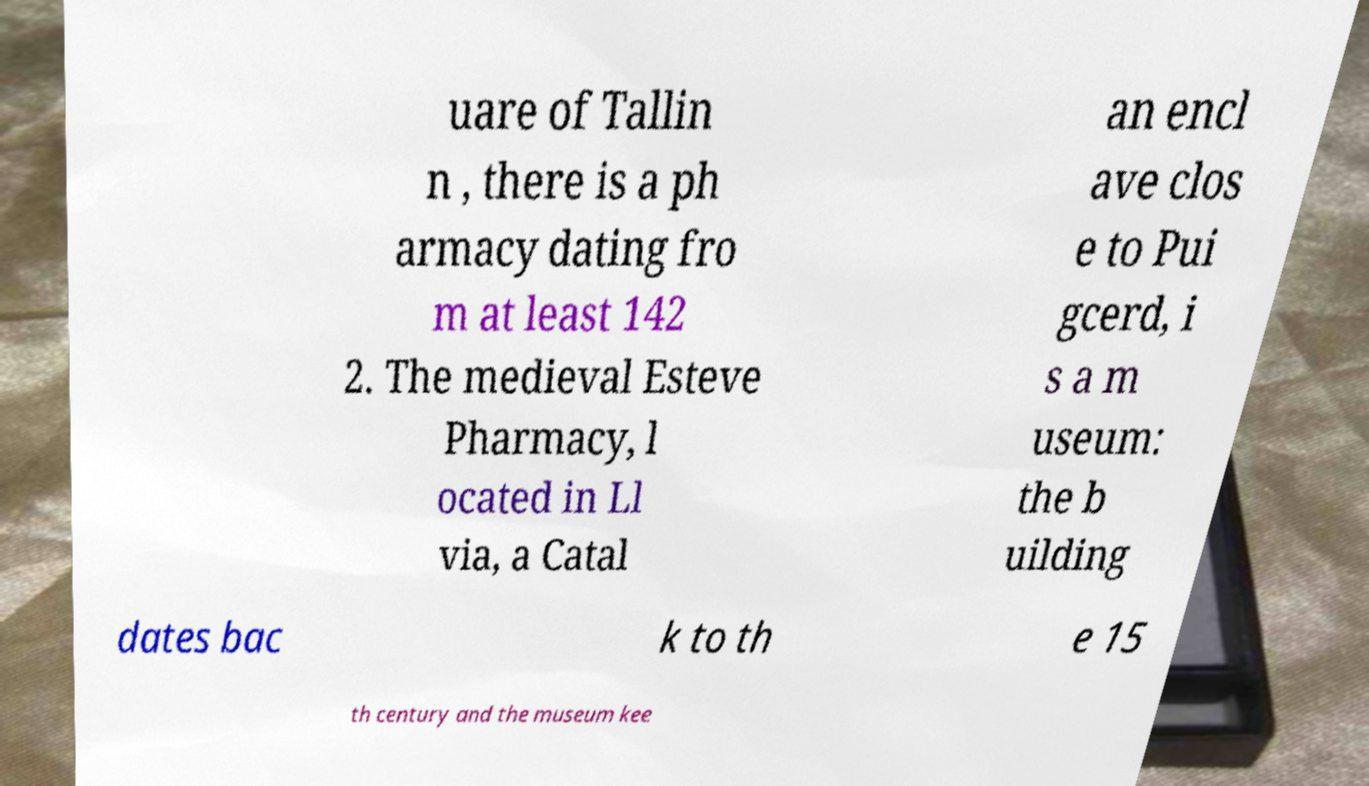I need the written content from this picture converted into text. Can you do that? uare of Tallin n , there is a ph armacy dating fro m at least 142 2. The medieval Esteve Pharmacy, l ocated in Ll via, a Catal an encl ave clos e to Pui gcerd, i s a m useum: the b uilding dates bac k to th e 15 th century and the museum kee 